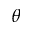Convert formula to latex. <formula><loc_0><loc_0><loc_500><loc_500>\theta</formula> 